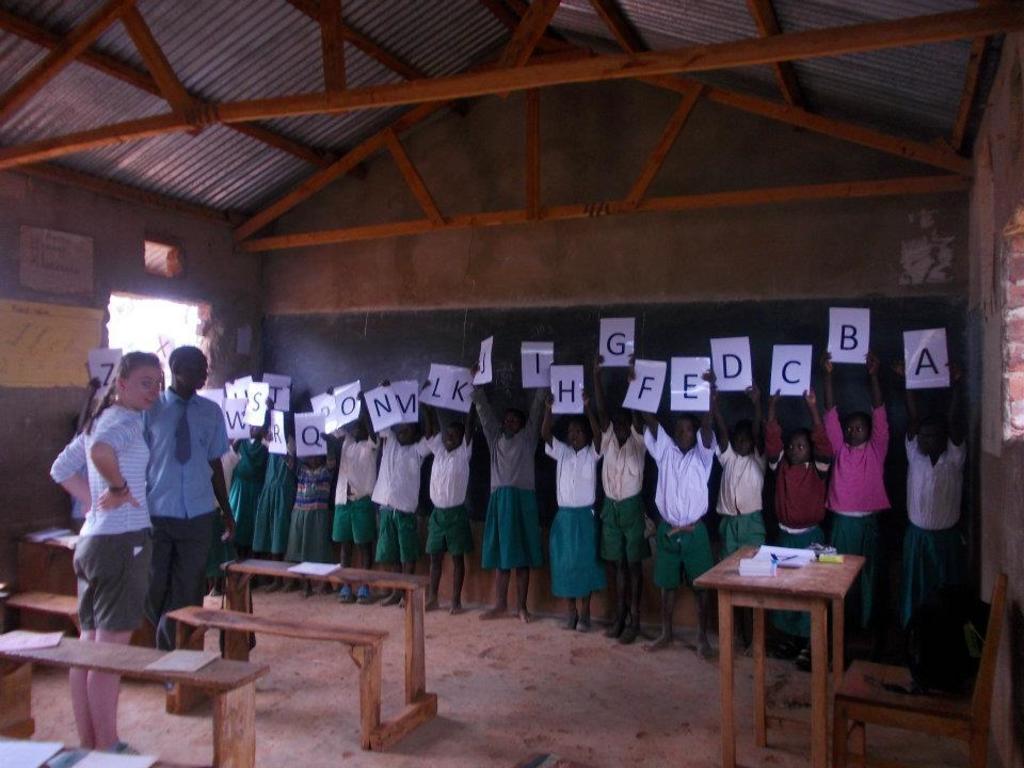In one or two sentences, can you explain what this image depicts? In this picture we can see a shelter, in that we can see a many children holding a boards alphabets and there we can see a table, benches and some papers on it, and books on the table and we can also see woman and a man standing near the benches, to the ceiling we can see a wooden sticks placed to the ceiling. 